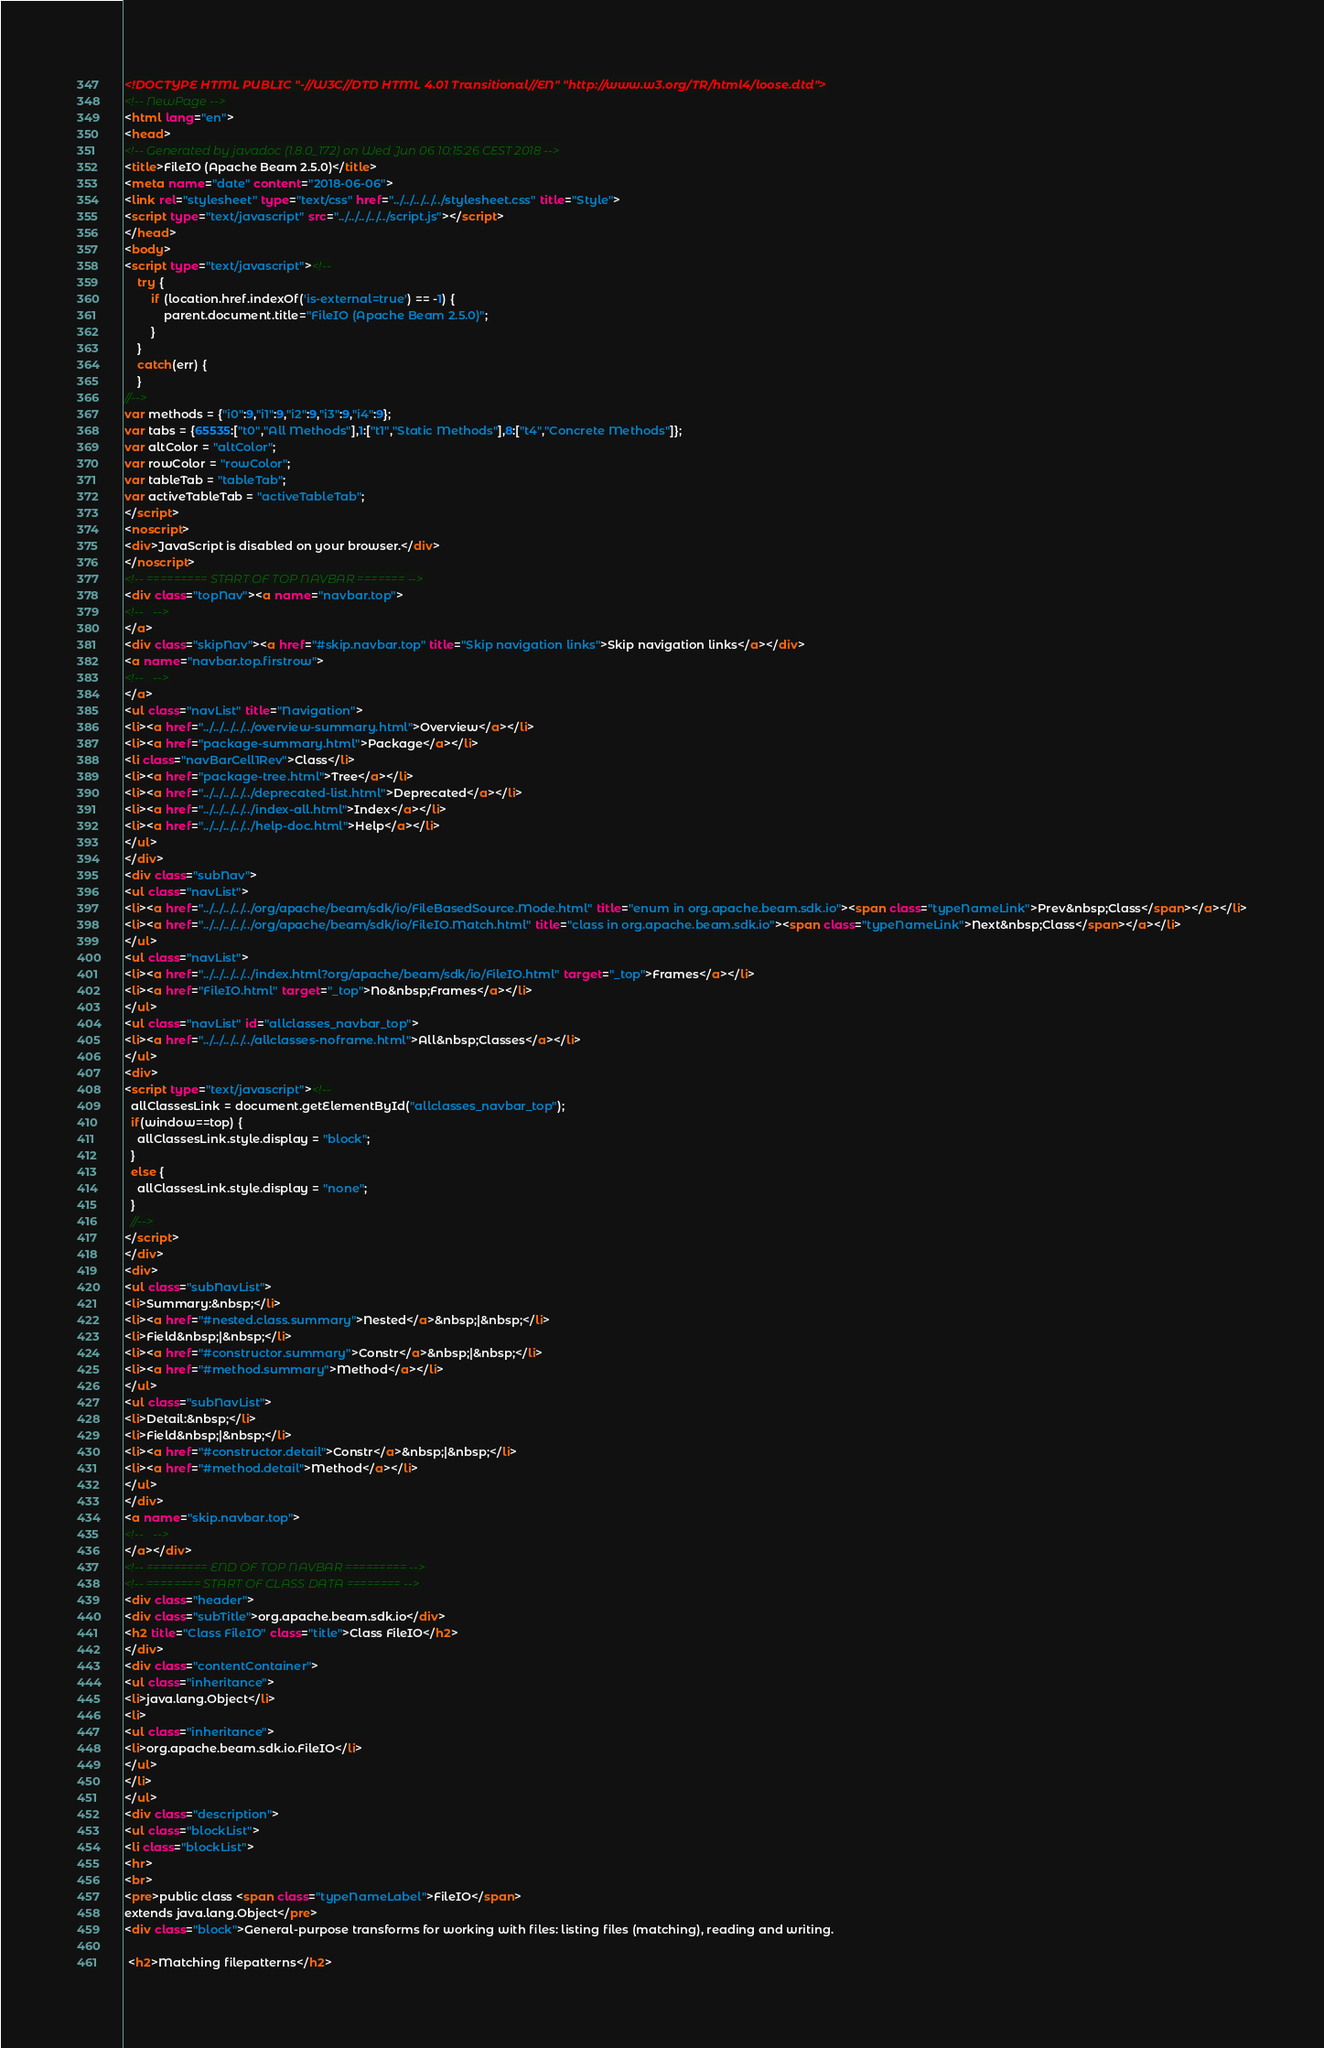Convert code to text. <code><loc_0><loc_0><loc_500><loc_500><_HTML_><!DOCTYPE HTML PUBLIC "-//W3C//DTD HTML 4.01 Transitional//EN" "http://www.w3.org/TR/html4/loose.dtd">
<!-- NewPage -->
<html lang="en">
<head>
<!-- Generated by javadoc (1.8.0_172) on Wed Jun 06 10:15:26 CEST 2018 -->
<title>FileIO (Apache Beam 2.5.0)</title>
<meta name="date" content="2018-06-06">
<link rel="stylesheet" type="text/css" href="../../../../../stylesheet.css" title="Style">
<script type="text/javascript" src="../../../../../script.js"></script>
</head>
<body>
<script type="text/javascript"><!--
    try {
        if (location.href.indexOf('is-external=true') == -1) {
            parent.document.title="FileIO (Apache Beam 2.5.0)";
        }
    }
    catch(err) {
    }
//-->
var methods = {"i0":9,"i1":9,"i2":9,"i3":9,"i4":9};
var tabs = {65535:["t0","All Methods"],1:["t1","Static Methods"],8:["t4","Concrete Methods"]};
var altColor = "altColor";
var rowColor = "rowColor";
var tableTab = "tableTab";
var activeTableTab = "activeTableTab";
</script>
<noscript>
<div>JavaScript is disabled on your browser.</div>
</noscript>
<!-- ========= START OF TOP NAVBAR ======= -->
<div class="topNav"><a name="navbar.top">
<!--   -->
</a>
<div class="skipNav"><a href="#skip.navbar.top" title="Skip navigation links">Skip navigation links</a></div>
<a name="navbar.top.firstrow">
<!--   -->
</a>
<ul class="navList" title="Navigation">
<li><a href="../../../../../overview-summary.html">Overview</a></li>
<li><a href="package-summary.html">Package</a></li>
<li class="navBarCell1Rev">Class</li>
<li><a href="package-tree.html">Tree</a></li>
<li><a href="../../../../../deprecated-list.html">Deprecated</a></li>
<li><a href="../../../../../index-all.html">Index</a></li>
<li><a href="../../../../../help-doc.html">Help</a></li>
</ul>
</div>
<div class="subNav">
<ul class="navList">
<li><a href="../../../../../org/apache/beam/sdk/io/FileBasedSource.Mode.html" title="enum in org.apache.beam.sdk.io"><span class="typeNameLink">Prev&nbsp;Class</span></a></li>
<li><a href="../../../../../org/apache/beam/sdk/io/FileIO.Match.html" title="class in org.apache.beam.sdk.io"><span class="typeNameLink">Next&nbsp;Class</span></a></li>
</ul>
<ul class="navList">
<li><a href="../../../../../index.html?org/apache/beam/sdk/io/FileIO.html" target="_top">Frames</a></li>
<li><a href="FileIO.html" target="_top">No&nbsp;Frames</a></li>
</ul>
<ul class="navList" id="allclasses_navbar_top">
<li><a href="../../../../../allclasses-noframe.html">All&nbsp;Classes</a></li>
</ul>
<div>
<script type="text/javascript"><!--
  allClassesLink = document.getElementById("allclasses_navbar_top");
  if(window==top) {
    allClassesLink.style.display = "block";
  }
  else {
    allClassesLink.style.display = "none";
  }
  //-->
</script>
</div>
<div>
<ul class="subNavList">
<li>Summary:&nbsp;</li>
<li><a href="#nested.class.summary">Nested</a>&nbsp;|&nbsp;</li>
<li>Field&nbsp;|&nbsp;</li>
<li><a href="#constructor.summary">Constr</a>&nbsp;|&nbsp;</li>
<li><a href="#method.summary">Method</a></li>
</ul>
<ul class="subNavList">
<li>Detail:&nbsp;</li>
<li>Field&nbsp;|&nbsp;</li>
<li><a href="#constructor.detail">Constr</a>&nbsp;|&nbsp;</li>
<li><a href="#method.detail">Method</a></li>
</ul>
</div>
<a name="skip.navbar.top">
<!--   -->
</a></div>
<!-- ========= END OF TOP NAVBAR ========= -->
<!-- ======== START OF CLASS DATA ======== -->
<div class="header">
<div class="subTitle">org.apache.beam.sdk.io</div>
<h2 title="Class FileIO" class="title">Class FileIO</h2>
</div>
<div class="contentContainer">
<ul class="inheritance">
<li>java.lang.Object</li>
<li>
<ul class="inheritance">
<li>org.apache.beam.sdk.io.FileIO</li>
</ul>
</li>
</ul>
<div class="description">
<ul class="blockList">
<li class="blockList">
<hr>
<br>
<pre>public class <span class="typeNameLabel">FileIO</span>
extends java.lang.Object</pre>
<div class="block">General-purpose transforms for working with files: listing files (matching), reading and writing.

 <h2>Matching filepatterns</h2>
</code> 